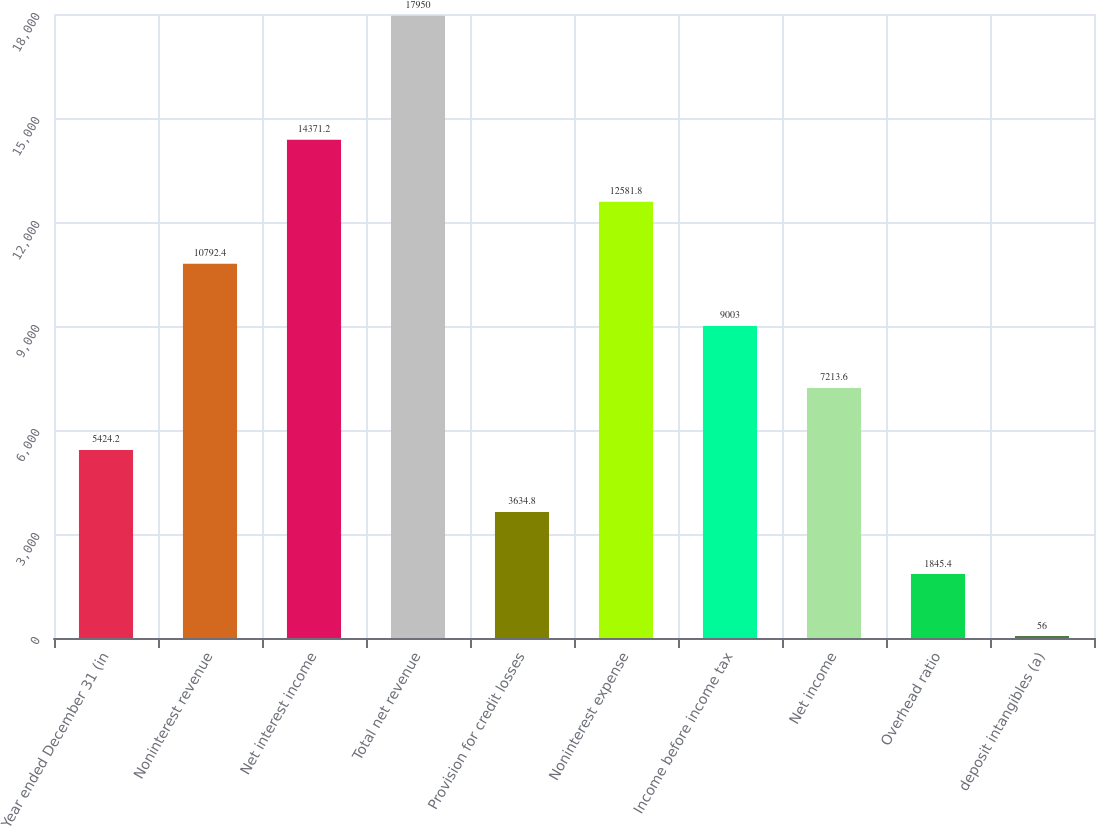<chart> <loc_0><loc_0><loc_500><loc_500><bar_chart><fcel>Year ended December 31 (in<fcel>Noninterest revenue<fcel>Net interest income<fcel>Total net revenue<fcel>Provision for credit losses<fcel>Noninterest expense<fcel>Income before income tax<fcel>Net income<fcel>Overhead ratio<fcel>deposit intangibles (a)<nl><fcel>5424.2<fcel>10792.4<fcel>14371.2<fcel>17950<fcel>3634.8<fcel>12581.8<fcel>9003<fcel>7213.6<fcel>1845.4<fcel>56<nl></chart> 